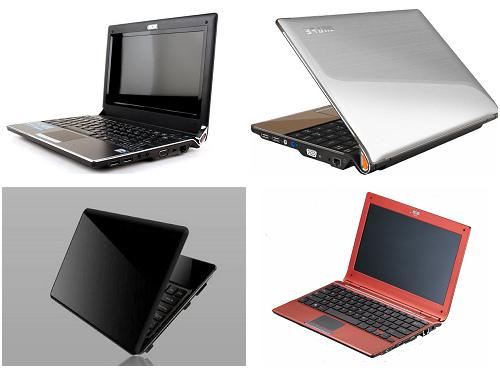Which one is the least open?
Write a very short answer. Bottom left. How many computers?
Concise answer only. 4. Are the Macbooks?
Write a very short answer. No. 